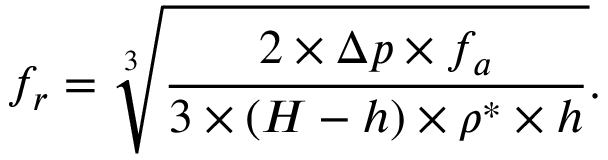Convert formula to latex. <formula><loc_0><loc_0><loc_500><loc_500>f _ { r } = \sqrt { [ } 3 ] { \frac { 2 \times \Delta p \times f _ { a } } { 3 \times ( H - h ) \times \rho ^ { * } \times h } } .</formula> 